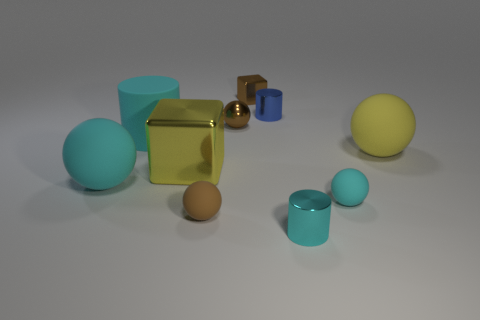Are there any cubes that have the same material as the big yellow sphere?
Your answer should be very brief. No. Are there fewer blue metallic cylinders to the left of the small brown metallic cube than cyan cylinders?
Make the answer very short. Yes. There is a cyan cylinder behind the large sphere on the left side of the large metallic object; what is its material?
Give a very brief answer. Rubber. What shape is the thing that is both on the left side of the small metal ball and in front of the large cyan rubber sphere?
Give a very brief answer. Sphere. What number of other things are the same color as the tiny block?
Ensure brevity in your answer.  2. What number of things are either metallic objects that are behind the big cyan cylinder or tiny brown metallic objects?
Your answer should be very brief. 3. Is the color of the big block the same as the small metallic cylinder that is behind the tiny cyan rubber object?
Keep it short and to the point. No. Is there anything else that is the same size as the cyan metallic cylinder?
Provide a succinct answer. Yes. How big is the brown sphere behind the rubber ball on the left side of the rubber cylinder?
Offer a very short reply. Small. What number of things are big yellow matte spheres or brown balls behind the big cyan rubber ball?
Provide a succinct answer. 2. 